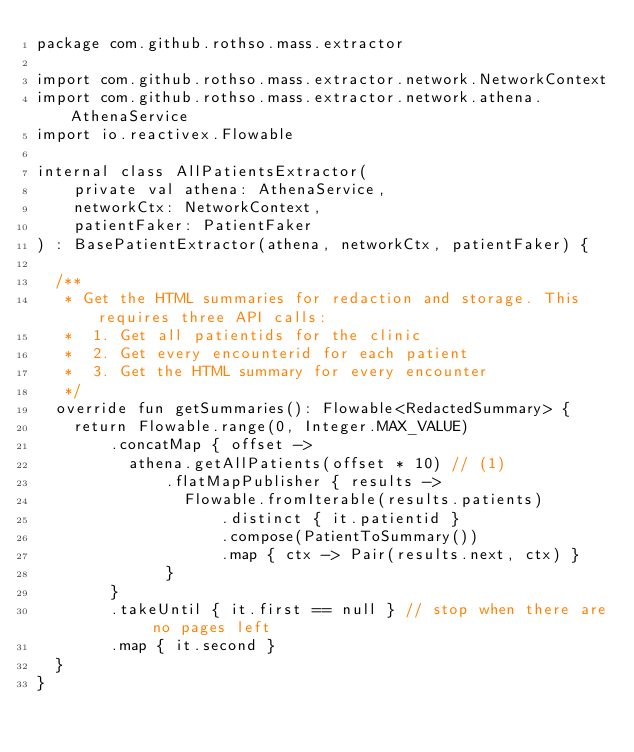Convert code to text. <code><loc_0><loc_0><loc_500><loc_500><_Kotlin_>package com.github.rothso.mass.extractor

import com.github.rothso.mass.extractor.network.NetworkContext
import com.github.rothso.mass.extractor.network.athena.AthenaService
import io.reactivex.Flowable

internal class AllPatientsExtractor(
    private val athena: AthenaService,
    networkCtx: NetworkContext,
    patientFaker: PatientFaker
) : BasePatientExtractor(athena, networkCtx, patientFaker) {

  /**
   * Get the HTML summaries for redaction and storage. This requires three API calls:
   *  1. Get all patientids for the clinic
   *  2. Get every encounterid for each patient
   *  3. Get the HTML summary for every encounter
   */
  override fun getSummaries(): Flowable<RedactedSummary> {
    return Flowable.range(0, Integer.MAX_VALUE)
        .concatMap { offset ->
          athena.getAllPatients(offset * 10) // (1)
              .flatMapPublisher { results ->
                Flowable.fromIterable(results.patients)
                    .distinct { it.patientid }
                    .compose(PatientToSummary())
                    .map { ctx -> Pair(results.next, ctx) }
              }
        }
        .takeUntil { it.first == null } // stop when there are no pages left
        .map { it.second }
  }
}</code> 